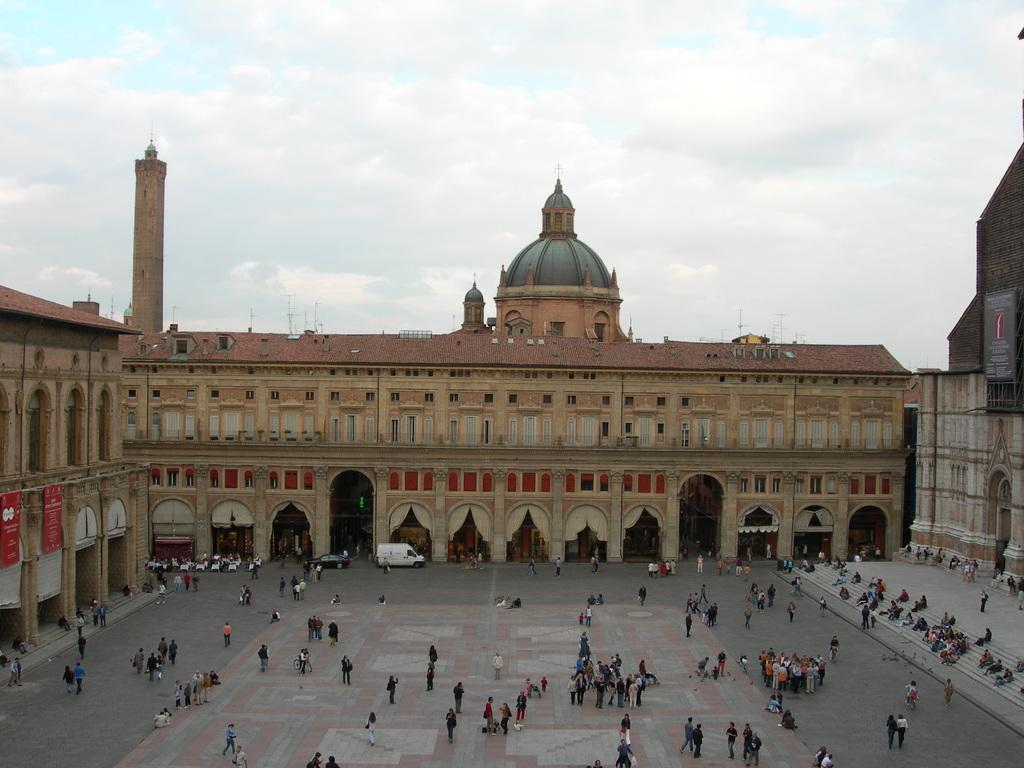What type of structures can be seen in the image? There are buildings in the image. What else is present in the image besides buildings? There are vehicles and people in the image. What is visible in the background of the image? The sky is visible in the image. What can be observed in the sky? Clouds are present in the sky. Can you tell me how many times the person in the image coughs? There is no indication in the image that anyone is coughing, so it cannot be determined from the picture. 